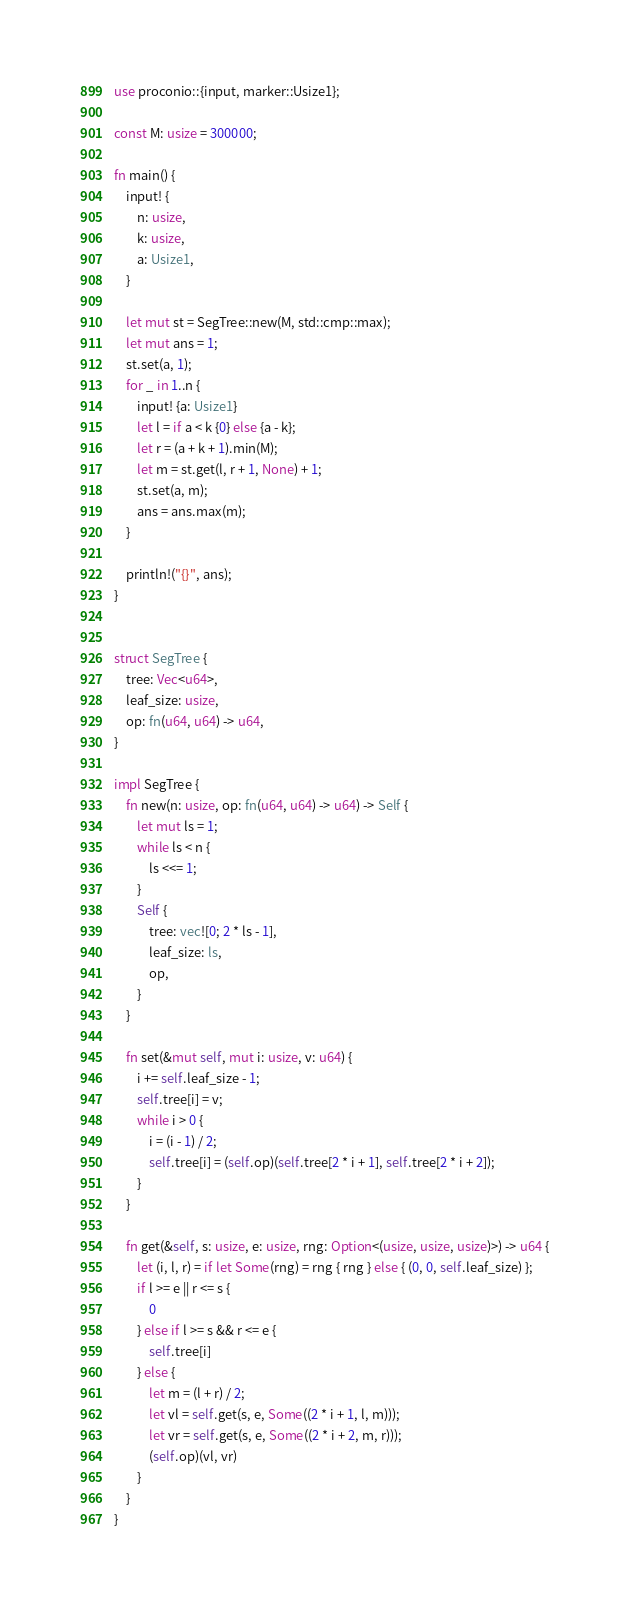Convert code to text. <code><loc_0><loc_0><loc_500><loc_500><_Rust_>use proconio::{input, marker::Usize1};

const M: usize = 300000;

fn main() {
    input! {
        n: usize,
        k: usize,
        a: Usize1,
    }

    let mut st = SegTree::new(M, std::cmp::max);
    let mut ans = 1;
    st.set(a, 1);
    for _ in 1..n {
        input! {a: Usize1}
        let l = if a < k {0} else {a - k};
        let r = (a + k + 1).min(M);
        let m = st.get(l, r + 1, None) + 1;
        st.set(a, m);
        ans = ans.max(m);
    }

    println!("{}", ans);
}


struct SegTree {
    tree: Vec<u64>,
    leaf_size: usize,
    op: fn(u64, u64) -> u64,
}

impl SegTree {
    fn new(n: usize, op: fn(u64, u64) -> u64) -> Self {
        let mut ls = 1;
        while ls < n {
            ls <<= 1;
        }
        Self {
            tree: vec![0; 2 * ls - 1],
            leaf_size: ls,
            op,
        }
    }

    fn set(&mut self, mut i: usize, v: u64) {
        i += self.leaf_size - 1;
        self.tree[i] = v;
        while i > 0 {
            i = (i - 1) / 2;
            self.tree[i] = (self.op)(self.tree[2 * i + 1], self.tree[2 * i + 2]);
        }
    }

    fn get(&self, s: usize, e: usize, rng: Option<(usize, usize, usize)>) -> u64 {
        let (i, l, r) = if let Some(rng) = rng { rng } else { (0, 0, self.leaf_size) };
        if l >= e || r <= s {
            0
        } else if l >= s && r <= e {
            self.tree[i]
        } else {
            let m = (l + r) / 2;
            let vl = self.get(s, e, Some((2 * i + 1, l, m)));
            let vr = self.get(s, e, Some((2 * i + 2, m, r)));
            (self.op)(vl, vr)
        }
    }
}
</code> 